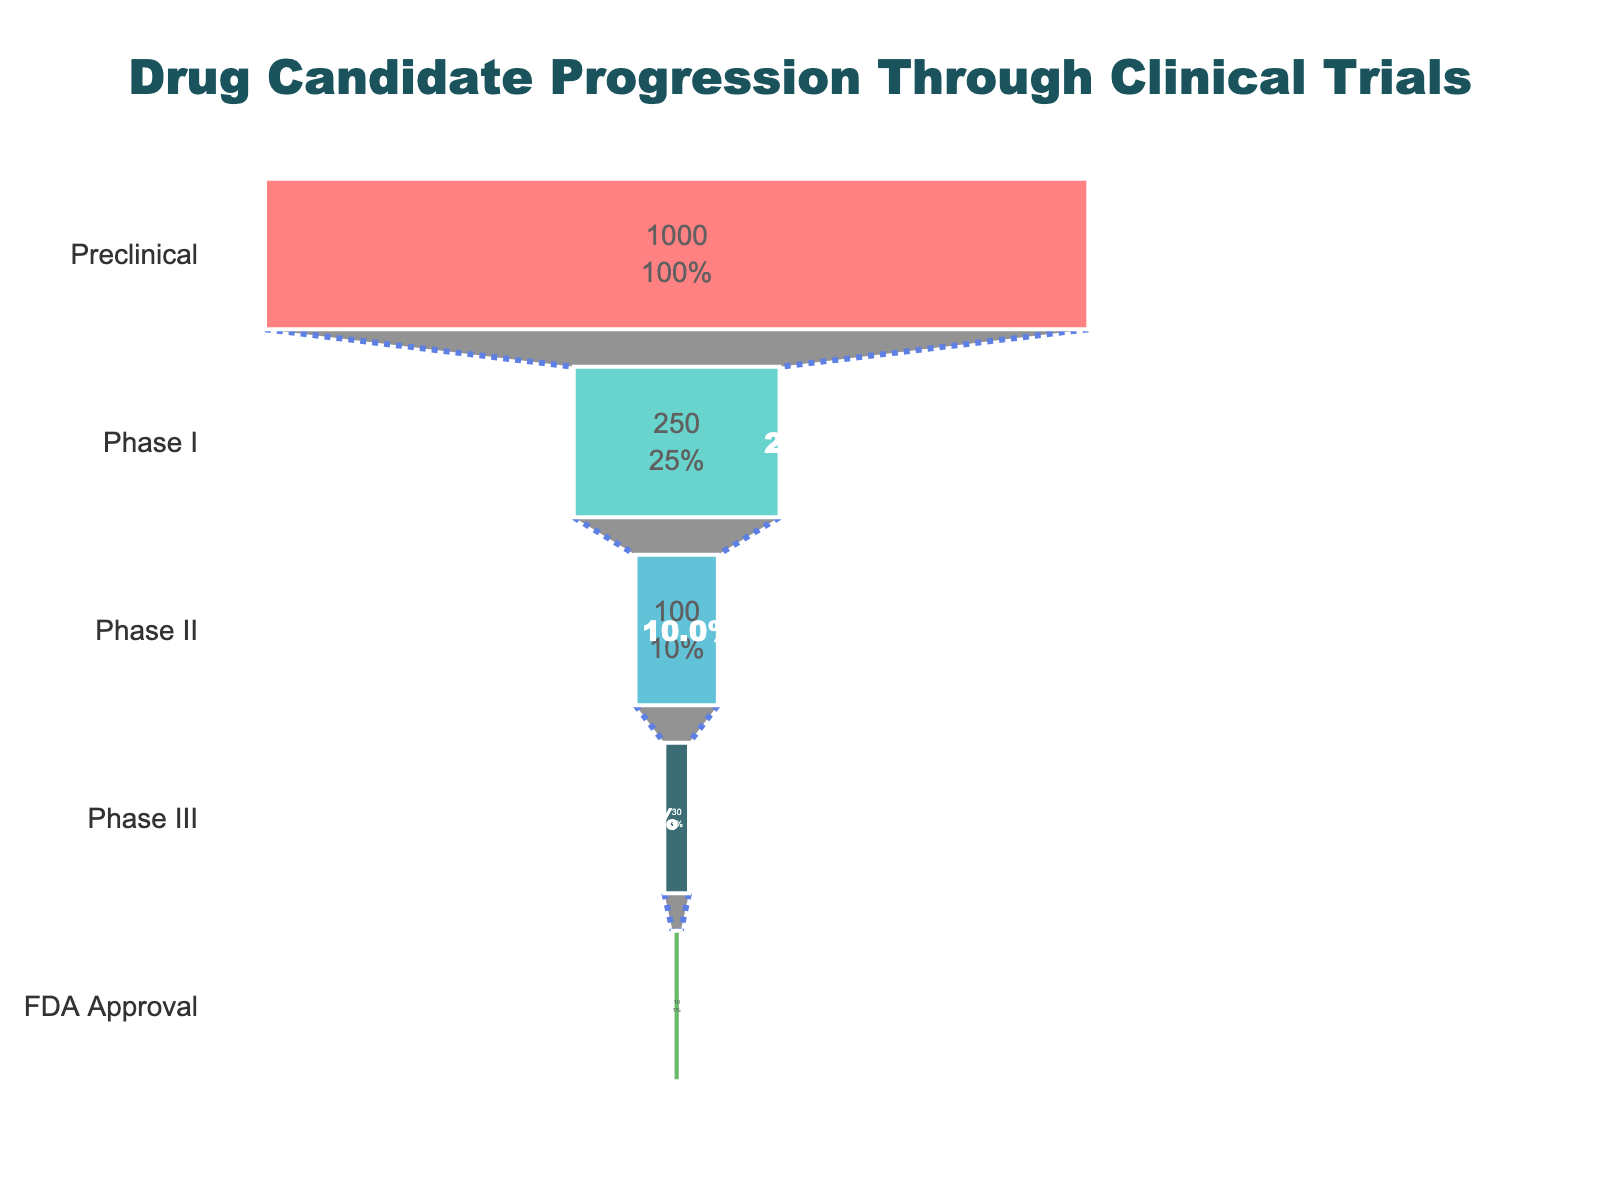What is the title of the funnel chart? The title is located at the top of the funnel chart, displayed prominently in larger font.
Answer: Drug Candidate Progression Through Clinical Trials How many drug candidates are there in Phase II? Look at the bar labeled "Phase II" in the funnel chart and note its associated number of drug candidates.
Answer: 100 What is the success rate in Phase III? The success rate is labeled next to or inside the bar for Phase III.
Answer: 3% How many drug candidates successfully reached FDA Approval from Phase I? First find the number of drug candidates at Phase I and FDA Approval. Then multiply the candidates in Phase I by their success rate to reach FDA Approval (250 * 0.01).
Answer: 2.5 Which phase has the highest drop in the number of drug candidates compared to the previous phase? Calculate the differences between the number of drug candidates in successive phases and find the largest drop. From Preclinical to Phase I is 750, Phase I to Phase II is 150, Phase II to Phase III is 70, and Phase III to FDA Approval is 20, with the largest being from Preclinical to Phase I.
Answer: Preclinical to Phase I What percentage of total initial drug candidates successfully reach Phase III? Start with the initial number of drug candidates in Preclinical (1000) and identify the number in Phase III (30). Calculate the percentage (30/1000 * 100).
Answer: 3% How does the success rate compare between Phase II and Phase III? Identify the success rates for Phase II (10%) and Phase III (3%) and compare them directly.
Answer: Phase II is higher What is the total decrease in drug candidates from Preclinical to FDA Approval? Calculate the number of drug candidates lost from Preclinical (1000) to FDA Approval (10). The decrease is 1000 - 10 = 990.
Answer: 990 If 20 more drug candidates were included at every phase, how many candidates would you expect to reach FDA Approval? Add 20 to each phase's number of candidates: Preclinical (1000 + 20), Phase I (250 + 20), etc. Then apply the success rates progressively: ((1000+20) * 0.25) = 255, ((255) * 0.40) ≈ 102, ((102) * 0.30) ≈ 30.6, and ((30.6) * 0.10) ≈ 13.06.
Answer: Approximately 13 